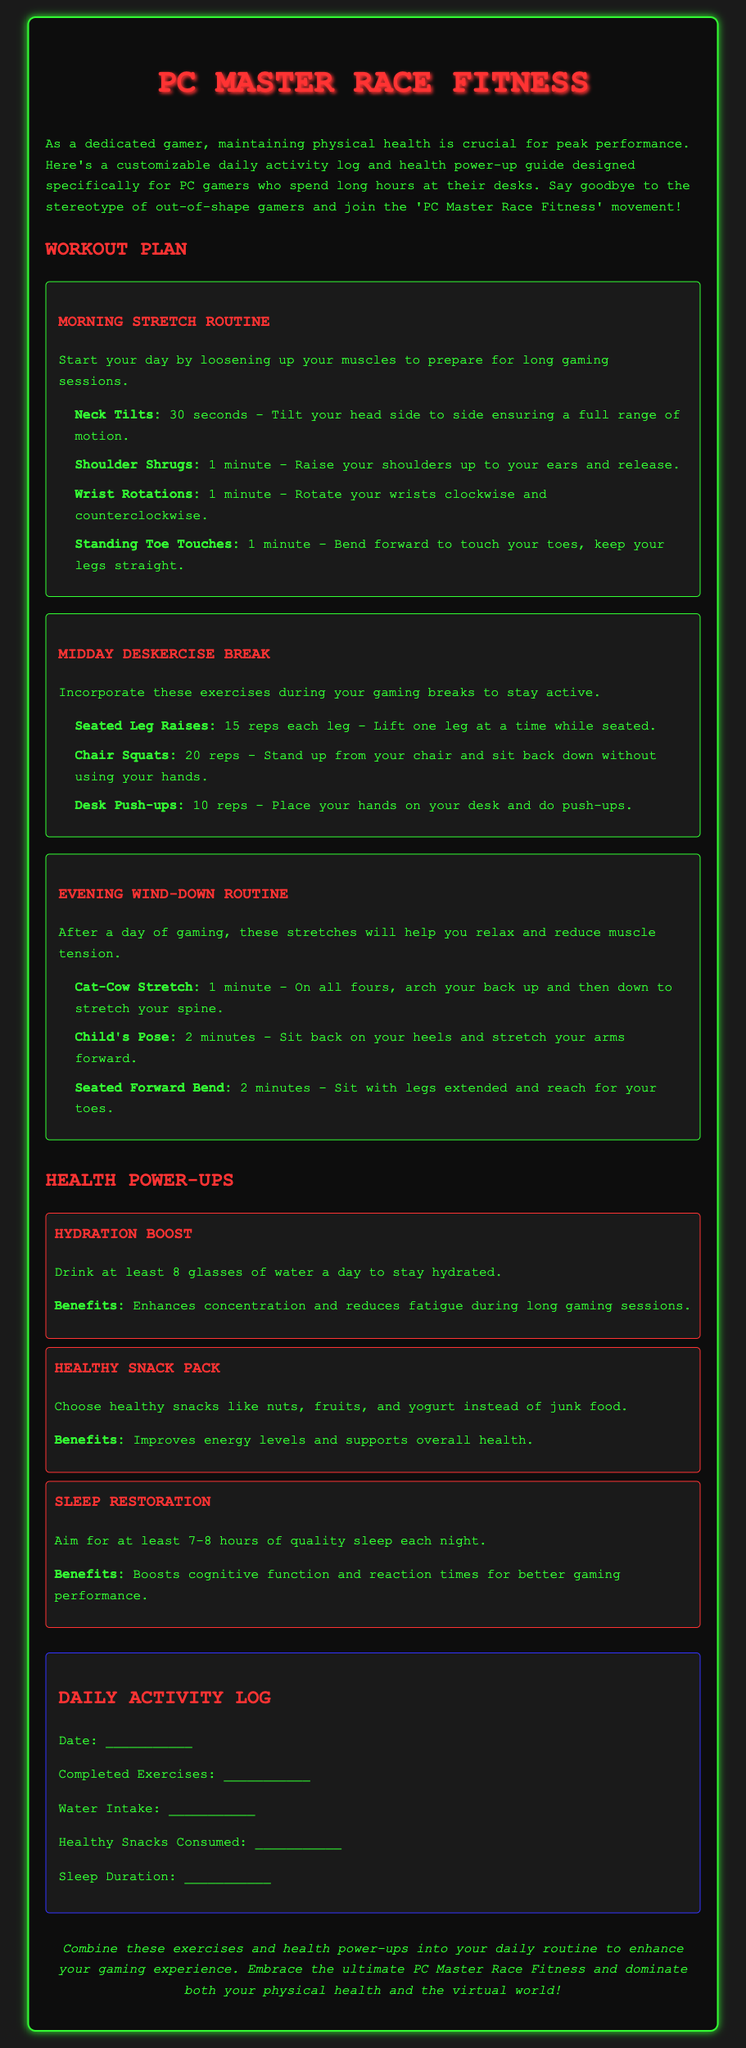What is the title of the document? The title of the document is stated prominently at the top of the rendered document.
Answer: PC Master Race Fitness What type of exercises are included in the Morning Stretch Routine? The Morning Stretch Routine contains exercises to help loosen muscles before gaming.
Answer: Stretches How long should you hold Neck Tilts? The duration for Neck Tilts is specified in the routine.
Answer: 30 seconds What is one benefit of the Hydration Boost? The benefits of the Hydration Boost are outlined in the power-up section.
Answer: Enhances concentration How many glasses of water should you drink daily according to the document? The document specifies a certain number of glasses for hydration.
Answer: 8 glasses What is the purpose of the Daily Activity Log? The Daily Activity Log allows users to track their daily activities related to health and fitness.
Answer: Track activities What is the recommended sleep duration each night? The recommended amount of sleep is mentioned in the Sleep Restoration power-up.
Answer: 7-8 hours What exercise is suggested as a part of the Midday Deskercise Break? Exercises during the Midday Deskercise Break are listed in the workout section.
Answer: Seated Leg Raises What color scheme does the document predominantly feature? The document's color scheme is visible throughout the background and text design.
Answer: Green and red 